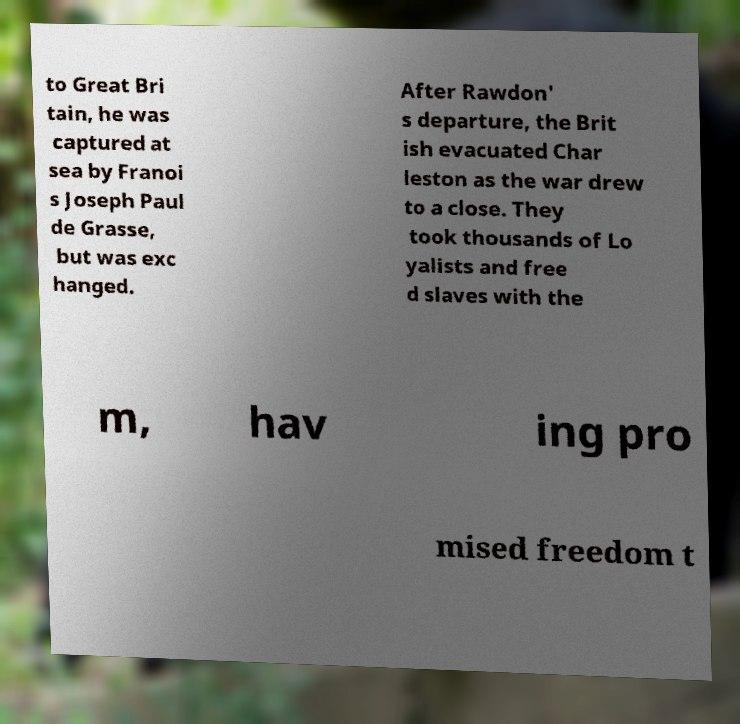Please identify and transcribe the text found in this image. to Great Bri tain, he was captured at sea by Franoi s Joseph Paul de Grasse, but was exc hanged. After Rawdon' s departure, the Brit ish evacuated Char leston as the war drew to a close. They took thousands of Lo yalists and free d slaves with the m, hav ing pro mised freedom t 